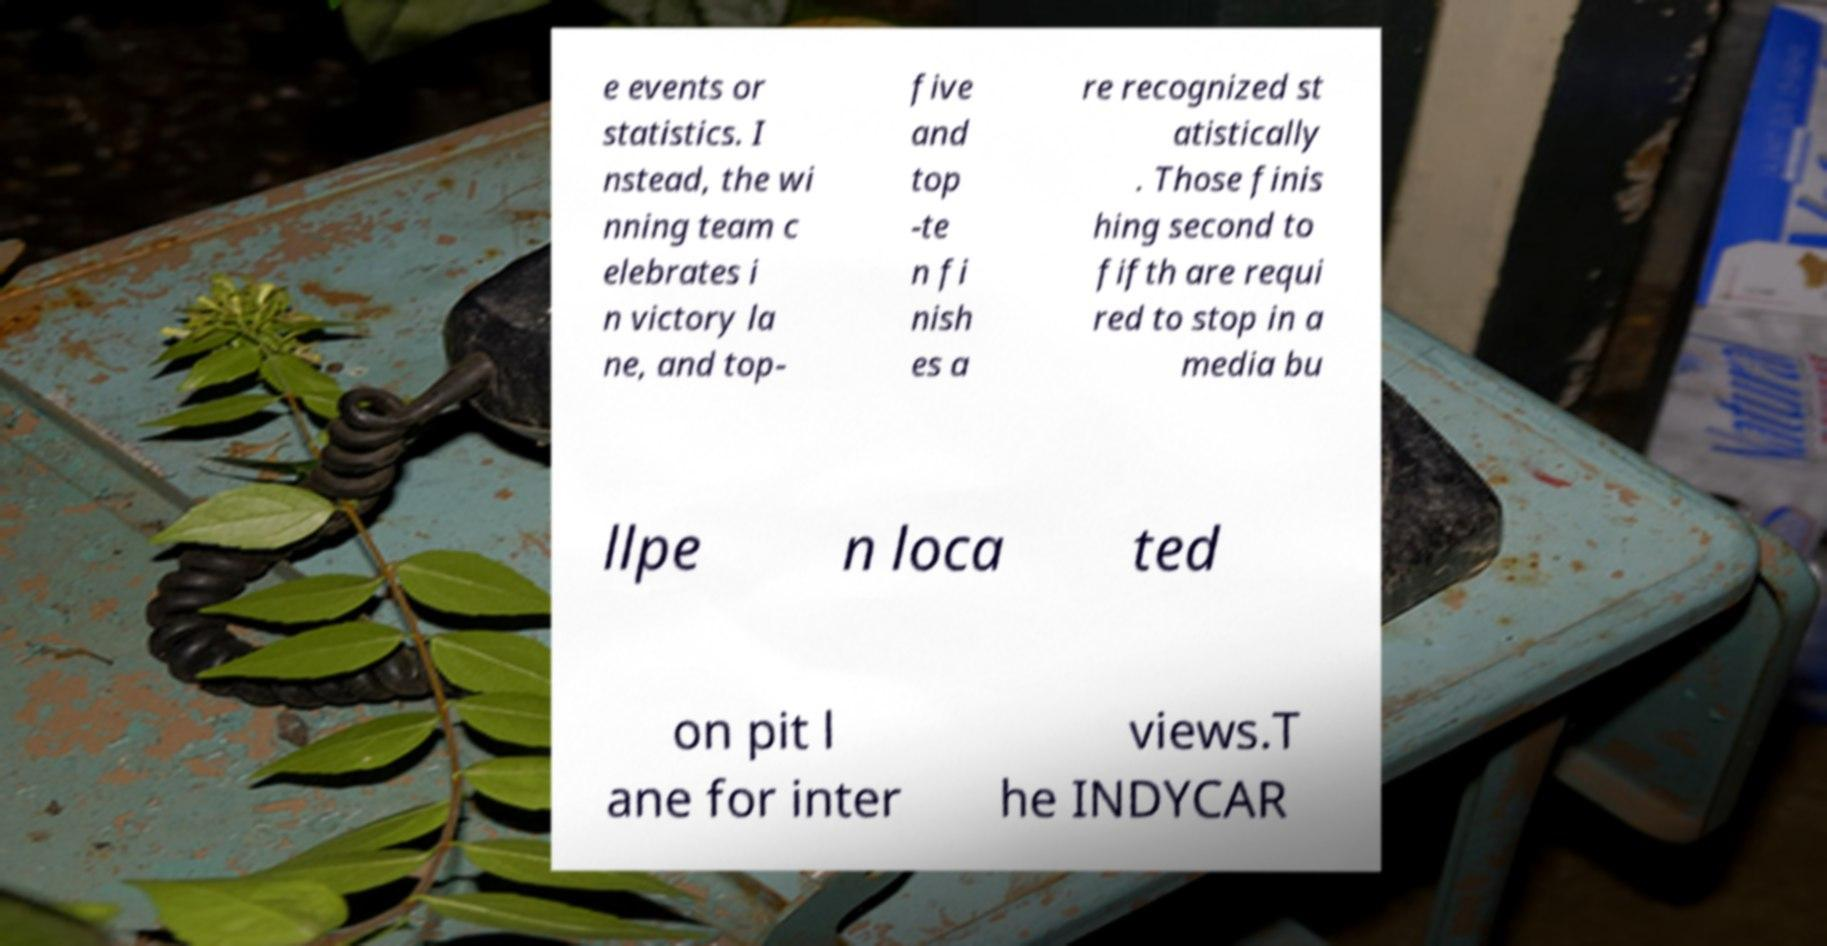Please identify and transcribe the text found in this image. e events or statistics. I nstead, the wi nning team c elebrates i n victory la ne, and top- five and top -te n fi nish es a re recognized st atistically . Those finis hing second to fifth are requi red to stop in a media bu llpe n loca ted on pit l ane for inter views.T he INDYCAR 